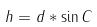<formula> <loc_0><loc_0><loc_500><loc_500>h = d * \sin C</formula> 